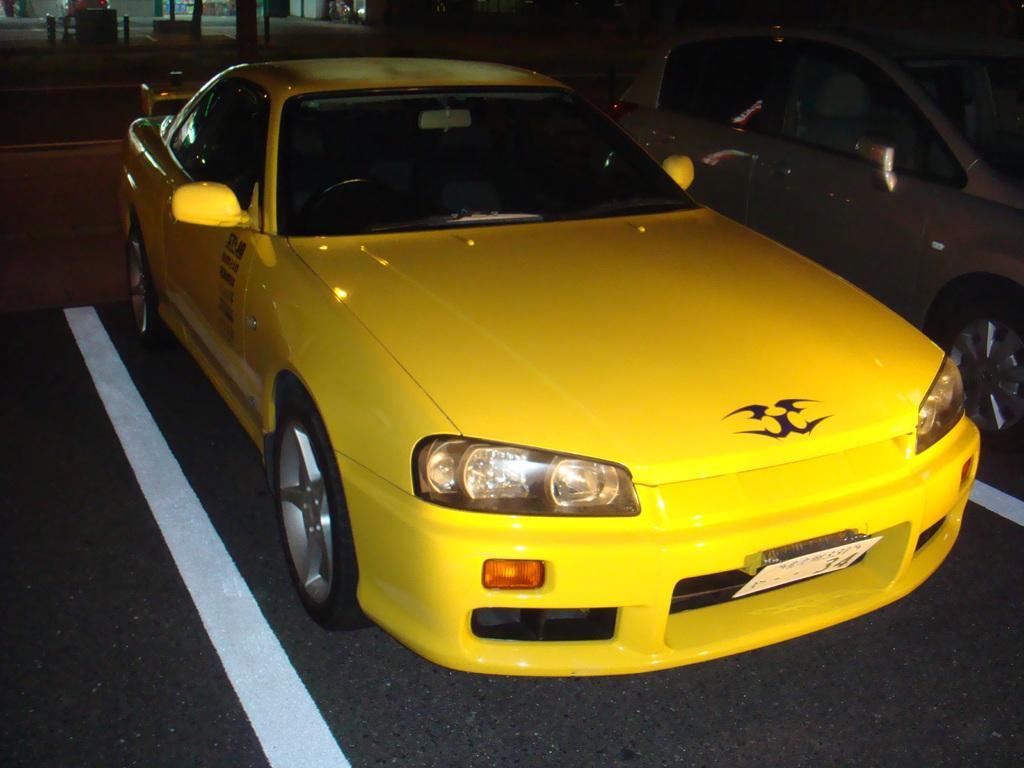How would you summarize this image in a sentence or two? In this image I can see a car and the car is in yellow color. Background I can see few poles and stalls, right I can also see the other car. 